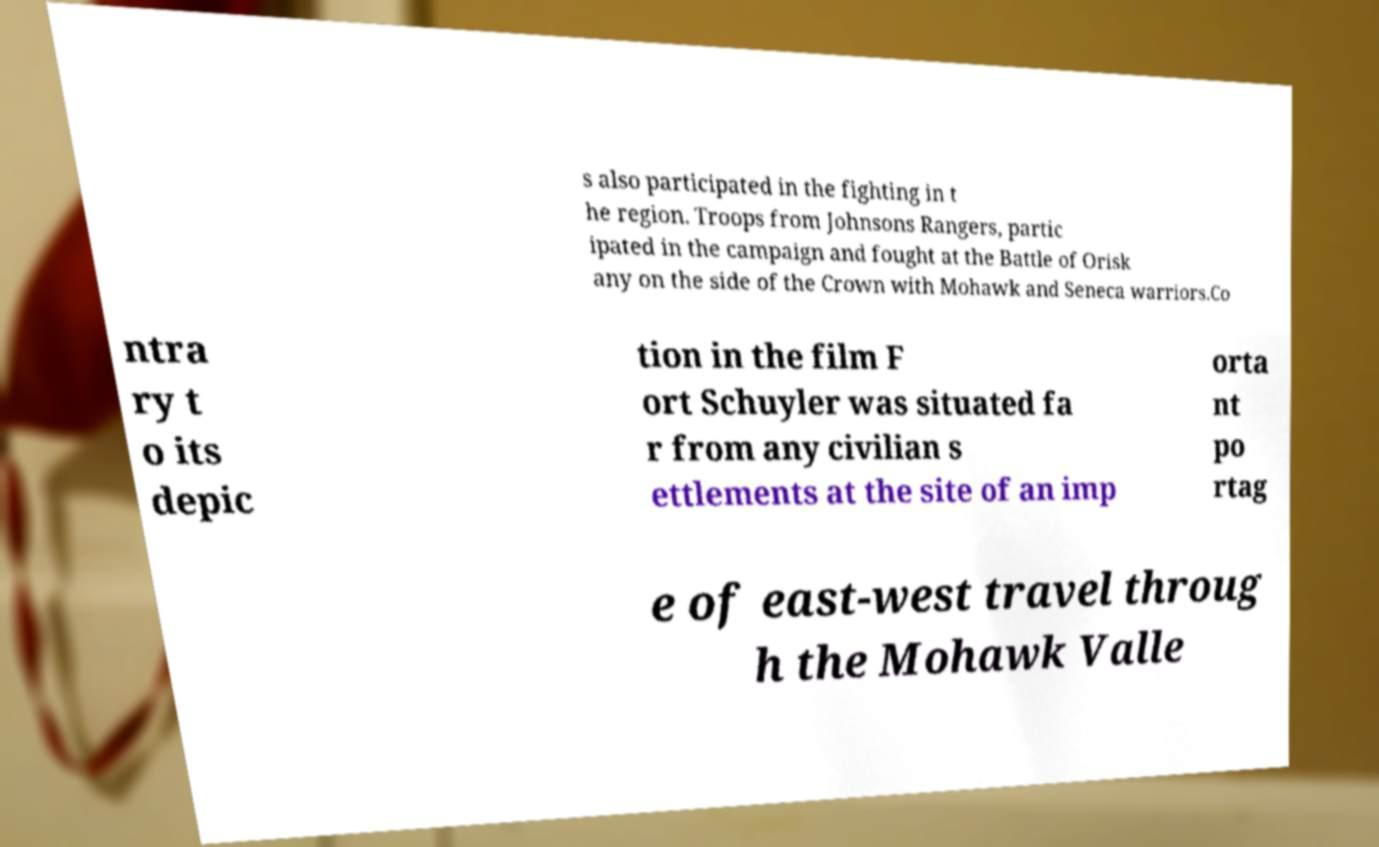Please identify and transcribe the text found in this image. s also participated in the fighting in t he region. Troops from Johnsons Rangers, partic ipated in the campaign and fought at the Battle of Orisk any on the side of the Crown with Mohawk and Seneca warriors.Co ntra ry t o its depic tion in the film F ort Schuyler was situated fa r from any civilian s ettlements at the site of an imp orta nt po rtag e of east-west travel throug h the Mohawk Valle 